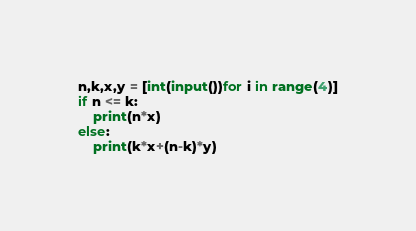Convert code to text. <code><loc_0><loc_0><loc_500><loc_500><_Python_>n,k,x,y = [int(input())for i in range(4)]
if n <= k:
    print(n*x)
else:
    print(k*x+(n-k)*y)</code> 